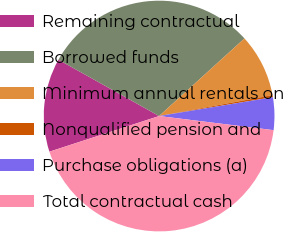<chart> <loc_0><loc_0><loc_500><loc_500><pie_chart><fcel>Remaining contractual<fcel>Borrowed funds<fcel>Minimum annual rentals on<fcel>Nonqualified pension and<fcel>Purchase obligations (a)<fcel>Total contractual cash<nl><fcel>13.12%<fcel>30.14%<fcel>8.84%<fcel>0.29%<fcel>4.57%<fcel>43.05%<nl></chart> 